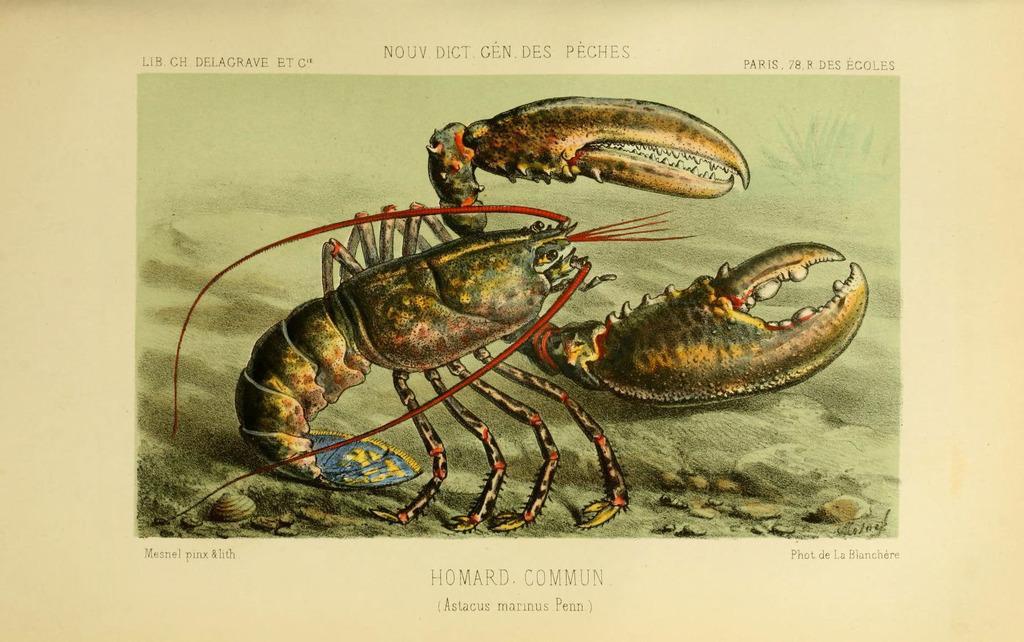In one or two sentences, can you explain what this image depicts? This is a graphical image of an american lobster. 